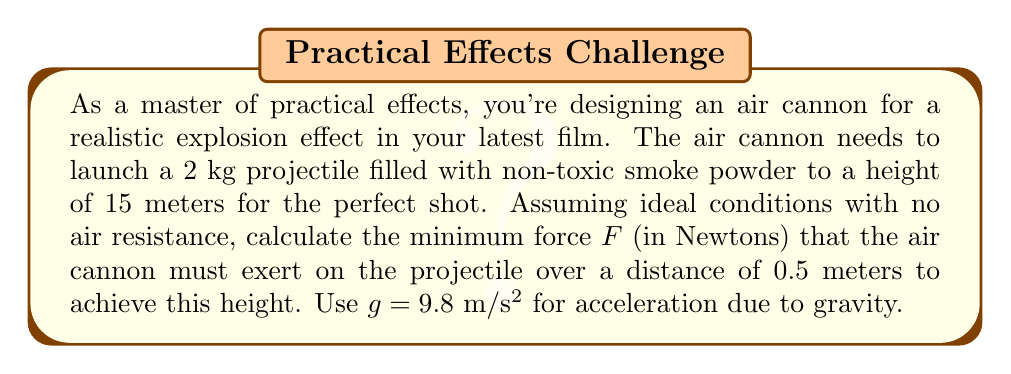What is the answer to this math problem? To solve this problem, we'll use conservation of energy and Newton's Second Law. Let's break it down step-by-step:

1) First, we need to find the initial velocity required for the projectile to reach a height of 15 meters. We can use the equation for maximum height:

   $$h = \frac{v_0^2}{2g}$$

   where $h$ is the maximum height, $v_0$ is the initial velocity, and $g$ is the acceleration due to gravity.

2) Rearranging this equation to solve for $v_0$:

   $$v_0 = \sqrt{2gh} = \sqrt{2 \cdot 9.8 \cdot 15} = 17.15 \text{ m/s}$$

3) Now that we know the required initial velocity, we can use the work-energy theorem to find the force. The work done by the force should equal the change in kinetic energy:

   $$W = \Delta KE$$
   $$Fd = \frac{1}{2}mv^2 - 0$$

   where $F$ is the force, $d$ is the distance over which the force is applied, $m$ is the mass of the projectile, and $v$ is the velocity.

4) Rearranging to solve for $F$:

   $$F = \frac{mv^2}{2d}$$

5) Plugging in our values:

   $$F = \frac{2 \cdot 17.15^2}{2 \cdot 0.5} = \frac{588.145}{1} = 588.145 \text{ N}$$

Therefore, the minimum force required is approximately 588.15 N.
Answer: $F \approx 588.15 \text{ N}$ 